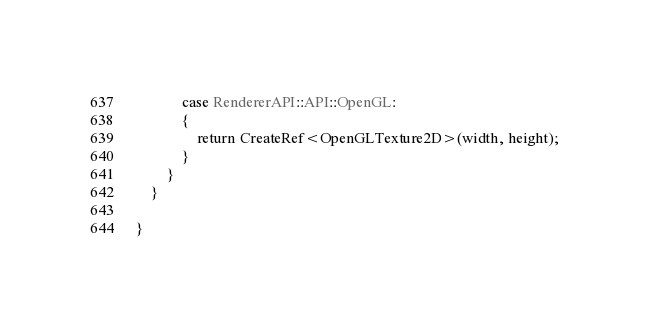Convert code to text. <code><loc_0><loc_0><loc_500><loc_500><_C++_>
			case RendererAPI::API::OpenGL:
			{
				return CreateRef<OpenGLTexture2D>(width, height);
			}
		}
	}

}</code> 